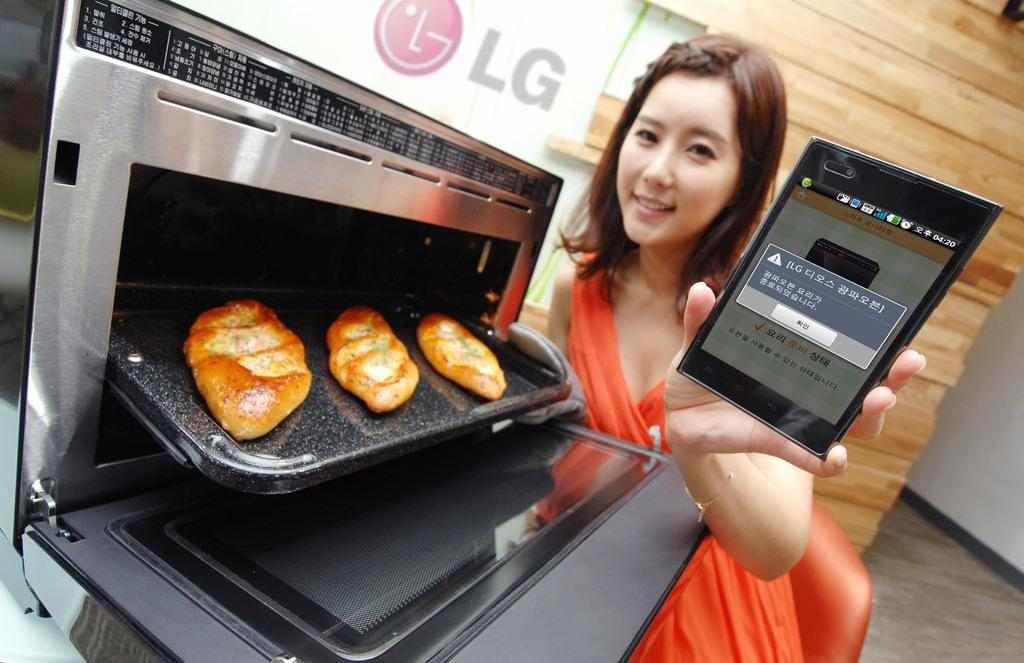What type of appliance can be seen in the image? There is an oven in the image. What other object is present in the image? There is a mobile in the image. What is on the tray that the woman is holding? There is a tray with food in the image. Can you identify the brand of the oven? Yes, there is an LG logo in the image, indicating that the oven is made by LG. Who is holding the tray and mobile in the image? A woman is holding the tray and mobile in the image. How many rabbits are hopping around in the image? There are no rabbits present in the image. 